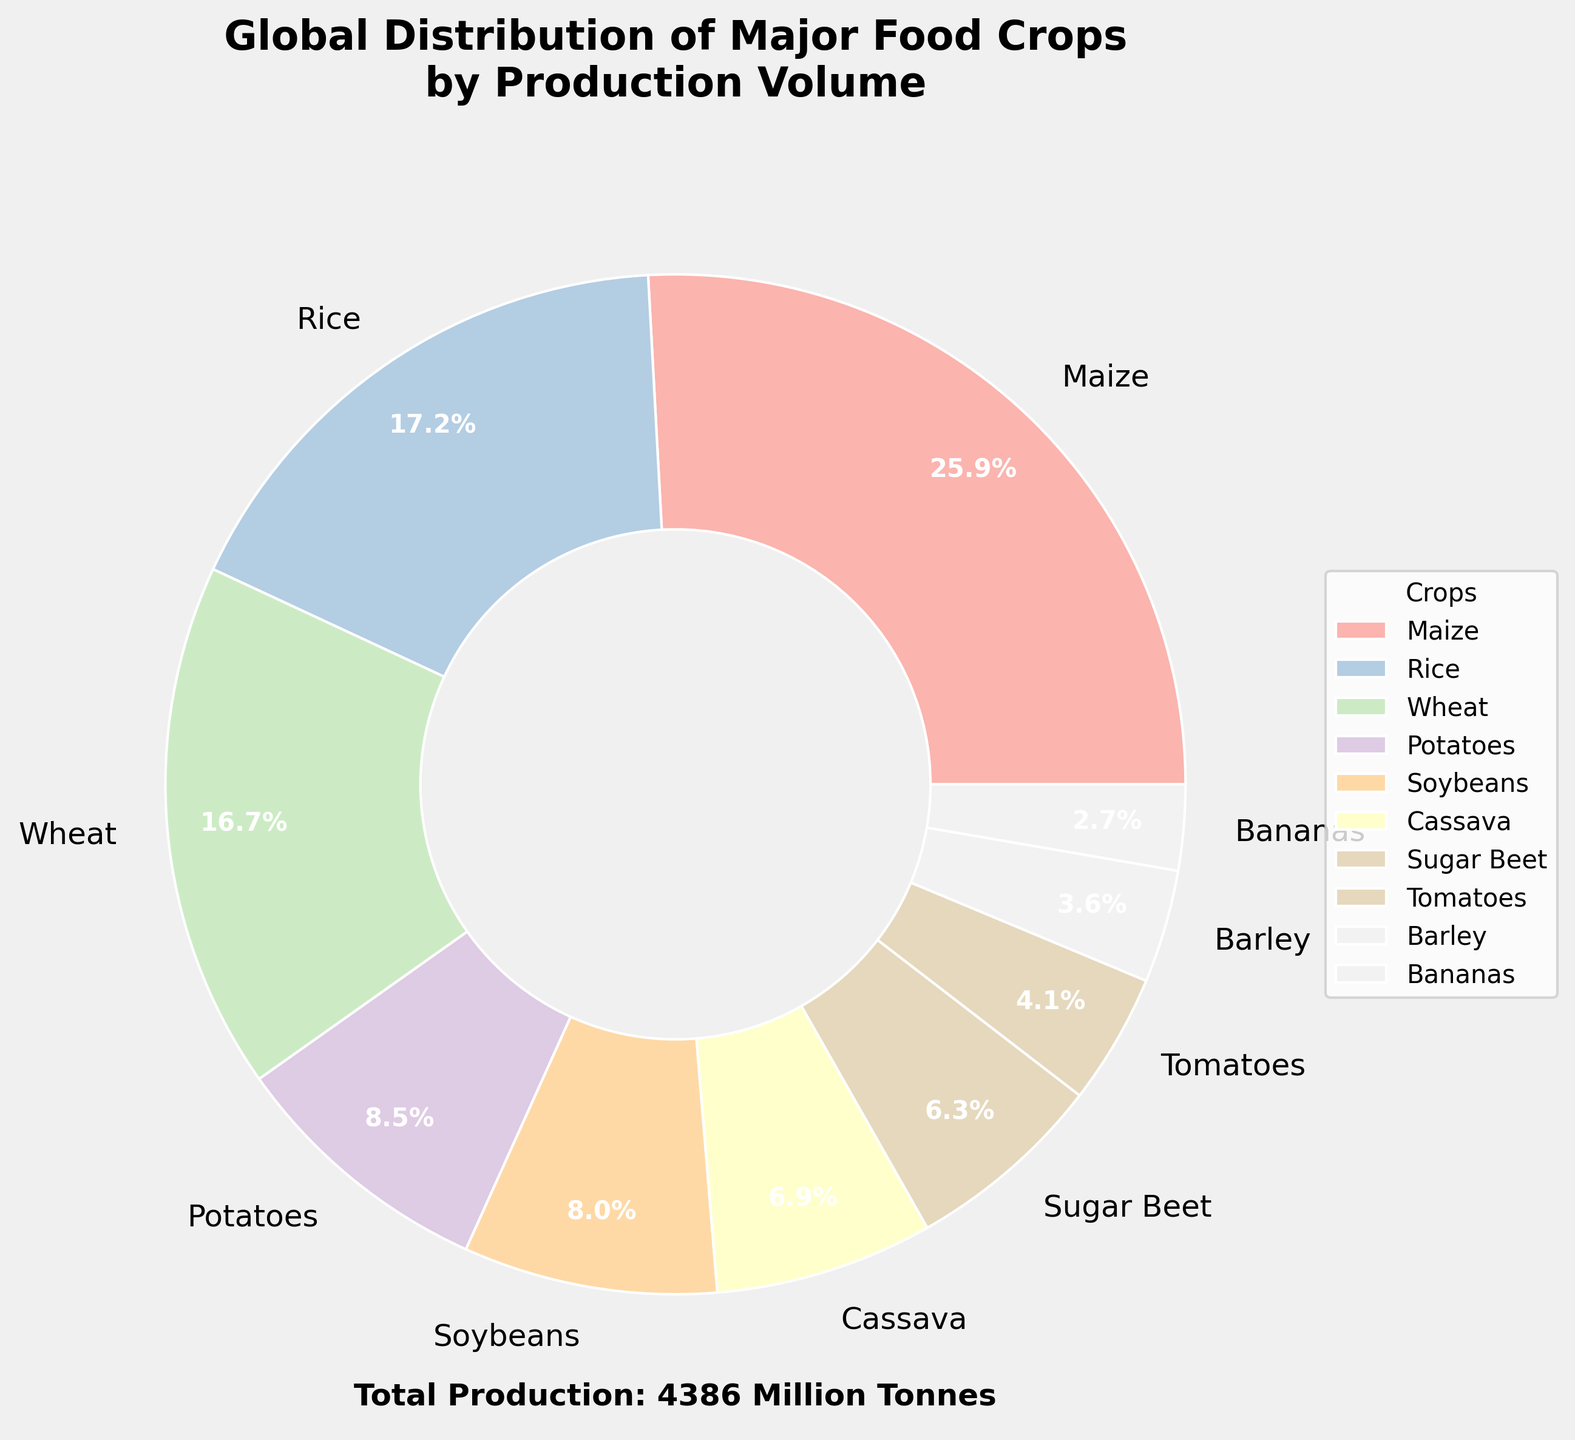Which crop has the highest production volume? The pie chart indicates that the segment representing Maize occupies the largest portion of the chart. Therefore, Maize has the highest production volume.
Answer: Maize What percentage of the total production volume is contributed by the top 3 crops? By looking at the pie chart, the top three crops are Maize, Rice, and Wheat. The provided percentages for these segments are 44.4% (Maize), 29.5% (Rice), and 28.7% (Wheat). Adding these percentages together gives 44.4% + 29.5% + 28.7% = 102.6%. However, since those segments were not accurate without knowing how the chart rounded the percentages, we use the exact data. The top three contributions are 1134, 755, and 734 million tonnes respectively. The total production of the top three crops is 1134 + 755 + 734 = 2623 million tonnes. The total production for top 10 crops is 1134 + 755 + 734 + 371 + 353 + 303 + 91 + 73 + 59 + 119 = 3992 million tonnes. Therefore, the top three crops' contribution is (2623 / 3992) * 100 = 65.7%.
Answer: 65.7% How does the production volume of Potatoes compare to that of Wheat? From the pie chart, the segment for Potatoes is smaller than that of Wheat. By referring to the percentages, Wheat has approximately 28.7% whereas Potatoes have around 8.1%. Specifically, the production volume for Potatoes (371 million tonnes) is significantly less than that for Wheat (734 million tonnes).
Answer: Less than Wheat Which crop has the least production volume among the top 10, and what is its percentage contribution? The smallest segment in the pie chart for the top 10 crops represents Yams. The label on this segment shows its percentage contribution, which is approximately 1.8%.
Answer: Yams, 1.8% How does the production volume of Tomatoes compare visually to that of Bananas? The segment representing Tomatoes is visibly larger than that of Bananas on the pie chart, meaning Tomatoes have a higher production volume.
Answer: Larger than Bananas Calculate the total production volume for Sweet Potatoes, Yams, and Sorghum combined. By referring to the provided data, we have Sweet Potatoes at 91 million tonnes, Yams at 73 million tonnes, and Sorghum at 59 million tonnes. Adding these volumes together, we get 91 + 73 + 59 = 223 million tonnes.
Answer: 223 million tonnes Which crop’s segment is represented by the lightest color among the top 10? Visually inspecting the pie chart, the segment with the lightest color corresponds to Soybeans.
Answer: Soybeans If you combined the production volumes of the crops ranked 4th and 5th, which crop's volume would it closely approximate? Potatoes are 371 million tonnes and Soybeans are 353 million tonnes. Combining these gives 371 + 353 = 724 million tonnes. This approximates the production volume of Wheat, which is 734 million tonnes.
Answer: Wheat How many crops contribute over 10% of the total production volume each? Referring to the percentages listed in the pie chart, only Maize (44.4%) and Rice (29.5%) have segments contributing over 10% of the total volume.
Answer: 2 